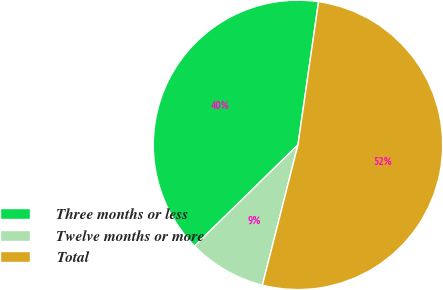Convert chart to OTSL. <chart><loc_0><loc_0><loc_500><loc_500><pie_chart><fcel>Three months or less<fcel>Twelve months or more<fcel>Total<nl><fcel>39.6%<fcel>8.72%<fcel>51.68%<nl></chart> 